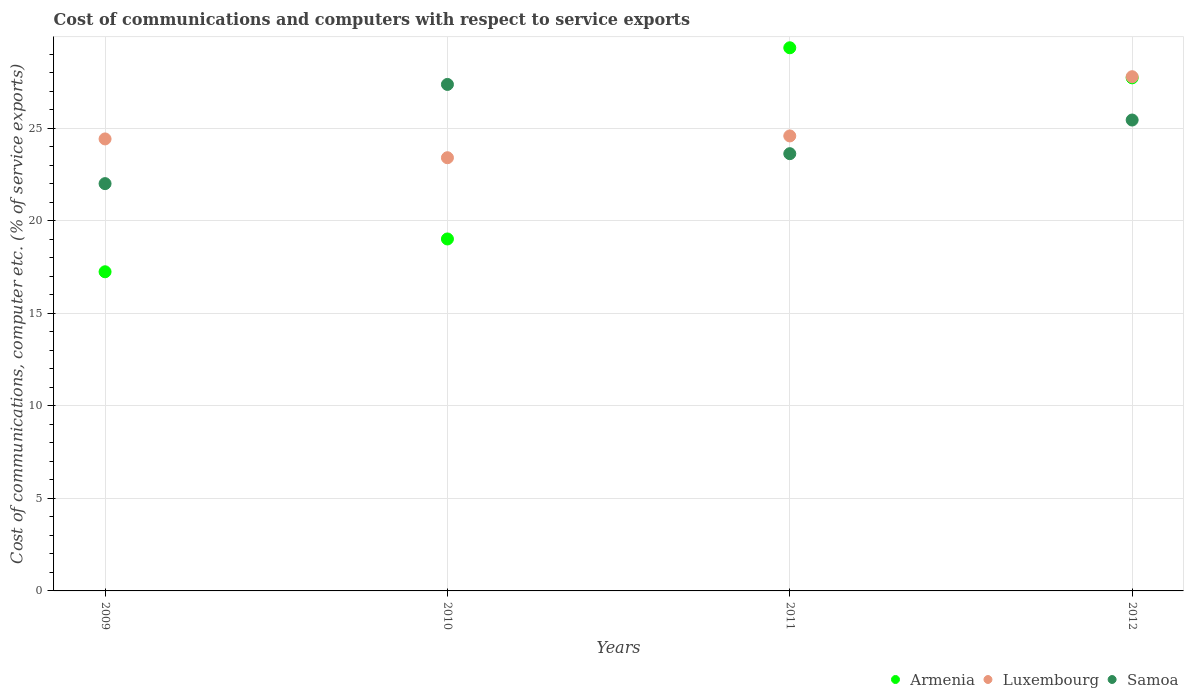Is the number of dotlines equal to the number of legend labels?
Your answer should be compact. Yes. What is the cost of communications and computers in Samoa in 2012?
Keep it short and to the point. 25.45. Across all years, what is the maximum cost of communications and computers in Samoa?
Ensure brevity in your answer.  27.37. Across all years, what is the minimum cost of communications and computers in Armenia?
Your response must be concise. 17.25. In which year was the cost of communications and computers in Samoa maximum?
Offer a very short reply. 2010. What is the total cost of communications and computers in Luxembourg in the graph?
Give a very brief answer. 100.22. What is the difference between the cost of communications and computers in Luxembourg in 2009 and that in 2011?
Give a very brief answer. -0.16. What is the difference between the cost of communications and computers in Luxembourg in 2011 and the cost of communications and computers in Armenia in 2012?
Ensure brevity in your answer.  -3.14. What is the average cost of communications and computers in Luxembourg per year?
Your answer should be very brief. 25.06. In the year 2011, what is the difference between the cost of communications and computers in Luxembourg and cost of communications and computers in Samoa?
Provide a short and direct response. 0.96. What is the ratio of the cost of communications and computers in Luxembourg in 2010 to that in 2011?
Ensure brevity in your answer.  0.95. Is the cost of communications and computers in Luxembourg in 2009 less than that in 2012?
Provide a short and direct response. Yes. Is the difference between the cost of communications and computers in Luxembourg in 2009 and 2010 greater than the difference between the cost of communications and computers in Samoa in 2009 and 2010?
Ensure brevity in your answer.  Yes. What is the difference between the highest and the second highest cost of communications and computers in Armenia?
Your answer should be very brief. 1.62. What is the difference between the highest and the lowest cost of communications and computers in Luxembourg?
Offer a terse response. 4.38. In how many years, is the cost of communications and computers in Armenia greater than the average cost of communications and computers in Armenia taken over all years?
Offer a very short reply. 2. Is the sum of the cost of communications and computers in Armenia in 2009 and 2012 greater than the maximum cost of communications and computers in Luxembourg across all years?
Keep it short and to the point. Yes. Is the cost of communications and computers in Armenia strictly greater than the cost of communications and computers in Luxembourg over the years?
Provide a succinct answer. No. Is the cost of communications and computers in Samoa strictly less than the cost of communications and computers in Luxembourg over the years?
Give a very brief answer. No. How many dotlines are there?
Ensure brevity in your answer.  3. How many years are there in the graph?
Make the answer very short. 4. What is the difference between two consecutive major ticks on the Y-axis?
Your response must be concise. 5. Are the values on the major ticks of Y-axis written in scientific E-notation?
Your response must be concise. No. Does the graph contain any zero values?
Keep it short and to the point. No. Does the graph contain grids?
Keep it short and to the point. Yes. What is the title of the graph?
Keep it short and to the point. Cost of communications and computers with respect to service exports. Does "Canada" appear as one of the legend labels in the graph?
Give a very brief answer. No. What is the label or title of the X-axis?
Provide a short and direct response. Years. What is the label or title of the Y-axis?
Your response must be concise. Cost of communications, computer etc. (% of service exports). What is the Cost of communications, computer etc. (% of service exports) of Armenia in 2009?
Your response must be concise. 17.25. What is the Cost of communications, computer etc. (% of service exports) of Luxembourg in 2009?
Offer a terse response. 24.43. What is the Cost of communications, computer etc. (% of service exports) of Samoa in 2009?
Your answer should be very brief. 22.01. What is the Cost of communications, computer etc. (% of service exports) in Armenia in 2010?
Your answer should be very brief. 19.02. What is the Cost of communications, computer etc. (% of service exports) of Luxembourg in 2010?
Ensure brevity in your answer.  23.41. What is the Cost of communications, computer etc. (% of service exports) of Samoa in 2010?
Provide a succinct answer. 27.37. What is the Cost of communications, computer etc. (% of service exports) in Armenia in 2011?
Provide a short and direct response. 29.35. What is the Cost of communications, computer etc. (% of service exports) in Luxembourg in 2011?
Provide a succinct answer. 24.59. What is the Cost of communications, computer etc. (% of service exports) in Samoa in 2011?
Provide a short and direct response. 23.63. What is the Cost of communications, computer etc. (% of service exports) in Armenia in 2012?
Ensure brevity in your answer.  27.73. What is the Cost of communications, computer etc. (% of service exports) of Luxembourg in 2012?
Give a very brief answer. 27.79. What is the Cost of communications, computer etc. (% of service exports) in Samoa in 2012?
Ensure brevity in your answer.  25.45. Across all years, what is the maximum Cost of communications, computer etc. (% of service exports) of Armenia?
Provide a short and direct response. 29.35. Across all years, what is the maximum Cost of communications, computer etc. (% of service exports) in Luxembourg?
Your response must be concise. 27.79. Across all years, what is the maximum Cost of communications, computer etc. (% of service exports) of Samoa?
Offer a terse response. 27.37. Across all years, what is the minimum Cost of communications, computer etc. (% of service exports) in Armenia?
Make the answer very short. 17.25. Across all years, what is the minimum Cost of communications, computer etc. (% of service exports) of Luxembourg?
Make the answer very short. 23.41. Across all years, what is the minimum Cost of communications, computer etc. (% of service exports) of Samoa?
Keep it short and to the point. 22.01. What is the total Cost of communications, computer etc. (% of service exports) of Armenia in the graph?
Offer a terse response. 93.35. What is the total Cost of communications, computer etc. (% of service exports) of Luxembourg in the graph?
Keep it short and to the point. 100.22. What is the total Cost of communications, computer etc. (% of service exports) of Samoa in the graph?
Provide a succinct answer. 98.47. What is the difference between the Cost of communications, computer etc. (% of service exports) of Armenia in 2009 and that in 2010?
Offer a very short reply. -1.77. What is the difference between the Cost of communications, computer etc. (% of service exports) of Luxembourg in 2009 and that in 2010?
Your answer should be very brief. 1.02. What is the difference between the Cost of communications, computer etc. (% of service exports) of Samoa in 2009 and that in 2010?
Give a very brief answer. -5.36. What is the difference between the Cost of communications, computer etc. (% of service exports) of Armenia in 2009 and that in 2011?
Your answer should be very brief. -12.11. What is the difference between the Cost of communications, computer etc. (% of service exports) in Luxembourg in 2009 and that in 2011?
Offer a terse response. -0.16. What is the difference between the Cost of communications, computer etc. (% of service exports) in Samoa in 2009 and that in 2011?
Your answer should be very brief. -1.62. What is the difference between the Cost of communications, computer etc. (% of service exports) of Armenia in 2009 and that in 2012?
Ensure brevity in your answer.  -10.48. What is the difference between the Cost of communications, computer etc. (% of service exports) in Luxembourg in 2009 and that in 2012?
Ensure brevity in your answer.  -3.36. What is the difference between the Cost of communications, computer etc. (% of service exports) of Samoa in 2009 and that in 2012?
Provide a short and direct response. -3.44. What is the difference between the Cost of communications, computer etc. (% of service exports) in Armenia in 2010 and that in 2011?
Provide a short and direct response. -10.33. What is the difference between the Cost of communications, computer etc. (% of service exports) in Luxembourg in 2010 and that in 2011?
Offer a very short reply. -1.18. What is the difference between the Cost of communications, computer etc. (% of service exports) in Samoa in 2010 and that in 2011?
Make the answer very short. 3.74. What is the difference between the Cost of communications, computer etc. (% of service exports) in Armenia in 2010 and that in 2012?
Ensure brevity in your answer.  -8.71. What is the difference between the Cost of communications, computer etc. (% of service exports) in Luxembourg in 2010 and that in 2012?
Your answer should be compact. -4.38. What is the difference between the Cost of communications, computer etc. (% of service exports) in Samoa in 2010 and that in 2012?
Keep it short and to the point. 1.92. What is the difference between the Cost of communications, computer etc. (% of service exports) in Armenia in 2011 and that in 2012?
Make the answer very short. 1.62. What is the difference between the Cost of communications, computer etc. (% of service exports) in Luxembourg in 2011 and that in 2012?
Offer a terse response. -3.2. What is the difference between the Cost of communications, computer etc. (% of service exports) in Samoa in 2011 and that in 2012?
Give a very brief answer. -1.82. What is the difference between the Cost of communications, computer etc. (% of service exports) of Armenia in 2009 and the Cost of communications, computer etc. (% of service exports) of Luxembourg in 2010?
Provide a short and direct response. -6.16. What is the difference between the Cost of communications, computer etc. (% of service exports) in Armenia in 2009 and the Cost of communications, computer etc. (% of service exports) in Samoa in 2010?
Keep it short and to the point. -10.13. What is the difference between the Cost of communications, computer etc. (% of service exports) in Luxembourg in 2009 and the Cost of communications, computer etc. (% of service exports) in Samoa in 2010?
Your answer should be very brief. -2.95. What is the difference between the Cost of communications, computer etc. (% of service exports) of Armenia in 2009 and the Cost of communications, computer etc. (% of service exports) of Luxembourg in 2011?
Offer a very short reply. -7.34. What is the difference between the Cost of communications, computer etc. (% of service exports) in Armenia in 2009 and the Cost of communications, computer etc. (% of service exports) in Samoa in 2011?
Your answer should be compact. -6.38. What is the difference between the Cost of communications, computer etc. (% of service exports) of Luxembourg in 2009 and the Cost of communications, computer etc. (% of service exports) of Samoa in 2011?
Your answer should be very brief. 0.8. What is the difference between the Cost of communications, computer etc. (% of service exports) of Armenia in 2009 and the Cost of communications, computer etc. (% of service exports) of Luxembourg in 2012?
Your answer should be compact. -10.54. What is the difference between the Cost of communications, computer etc. (% of service exports) of Armenia in 2009 and the Cost of communications, computer etc. (% of service exports) of Samoa in 2012?
Keep it short and to the point. -8.2. What is the difference between the Cost of communications, computer etc. (% of service exports) of Luxembourg in 2009 and the Cost of communications, computer etc. (% of service exports) of Samoa in 2012?
Offer a terse response. -1.02. What is the difference between the Cost of communications, computer etc. (% of service exports) of Armenia in 2010 and the Cost of communications, computer etc. (% of service exports) of Luxembourg in 2011?
Provide a succinct answer. -5.57. What is the difference between the Cost of communications, computer etc. (% of service exports) in Armenia in 2010 and the Cost of communications, computer etc. (% of service exports) in Samoa in 2011?
Your response must be concise. -4.61. What is the difference between the Cost of communications, computer etc. (% of service exports) in Luxembourg in 2010 and the Cost of communications, computer etc. (% of service exports) in Samoa in 2011?
Provide a short and direct response. -0.22. What is the difference between the Cost of communications, computer etc. (% of service exports) in Armenia in 2010 and the Cost of communications, computer etc. (% of service exports) in Luxembourg in 2012?
Give a very brief answer. -8.77. What is the difference between the Cost of communications, computer etc. (% of service exports) of Armenia in 2010 and the Cost of communications, computer etc. (% of service exports) of Samoa in 2012?
Provide a succinct answer. -6.43. What is the difference between the Cost of communications, computer etc. (% of service exports) of Luxembourg in 2010 and the Cost of communications, computer etc. (% of service exports) of Samoa in 2012?
Ensure brevity in your answer.  -2.04. What is the difference between the Cost of communications, computer etc. (% of service exports) of Armenia in 2011 and the Cost of communications, computer etc. (% of service exports) of Luxembourg in 2012?
Your answer should be compact. 1.56. What is the difference between the Cost of communications, computer etc. (% of service exports) in Armenia in 2011 and the Cost of communications, computer etc. (% of service exports) in Samoa in 2012?
Ensure brevity in your answer.  3.9. What is the difference between the Cost of communications, computer etc. (% of service exports) of Luxembourg in 2011 and the Cost of communications, computer etc. (% of service exports) of Samoa in 2012?
Your response must be concise. -0.86. What is the average Cost of communications, computer etc. (% of service exports) in Armenia per year?
Provide a short and direct response. 23.34. What is the average Cost of communications, computer etc. (% of service exports) in Luxembourg per year?
Provide a succinct answer. 25.06. What is the average Cost of communications, computer etc. (% of service exports) in Samoa per year?
Offer a very short reply. 24.62. In the year 2009, what is the difference between the Cost of communications, computer etc. (% of service exports) of Armenia and Cost of communications, computer etc. (% of service exports) of Luxembourg?
Give a very brief answer. -7.18. In the year 2009, what is the difference between the Cost of communications, computer etc. (% of service exports) in Armenia and Cost of communications, computer etc. (% of service exports) in Samoa?
Your answer should be compact. -4.76. In the year 2009, what is the difference between the Cost of communications, computer etc. (% of service exports) in Luxembourg and Cost of communications, computer etc. (% of service exports) in Samoa?
Make the answer very short. 2.42. In the year 2010, what is the difference between the Cost of communications, computer etc. (% of service exports) in Armenia and Cost of communications, computer etc. (% of service exports) in Luxembourg?
Your answer should be very brief. -4.39. In the year 2010, what is the difference between the Cost of communications, computer etc. (% of service exports) in Armenia and Cost of communications, computer etc. (% of service exports) in Samoa?
Provide a succinct answer. -8.35. In the year 2010, what is the difference between the Cost of communications, computer etc. (% of service exports) of Luxembourg and Cost of communications, computer etc. (% of service exports) of Samoa?
Your answer should be very brief. -3.96. In the year 2011, what is the difference between the Cost of communications, computer etc. (% of service exports) in Armenia and Cost of communications, computer etc. (% of service exports) in Luxembourg?
Your answer should be very brief. 4.76. In the year 2011, what is the difference between the Cost of communications, computer etc. (% of service exports) in Armenia and Cost of communications, computer etc. (% of service exports) in Samoa?
Your answer should be very brief. 5.72. In the year 2011, what is the difference between the Cost of communications, computer etc. (% of service exports) of Luxembourg and Cost of communications, computer etc. (% of service exports) of Samoa?
Make the answer very short. 0.96. In the year 2012, what is the difference between the Cost of communications, computer etc. (% of service exports) in Armenia and Cost of communications, computer etc. (% of service exports) in Luxembourg?
Provide a succinct answer. -0.06. In the year 2012, what is the difference between the Cost of communications, computer etc. (% of service exports) of Armenia and Cost of communications, computer etc. (% of service exports) of Samoa?
Your answer should be very brief. 2.28. In the year 2012, what is the difference between the Cost of communications, computer etc. (% of service exports) of Luxembourg and Cost of communications, computer etc. (% of service exports) of Samoa?
Your response must be concise. 2.34. What is the ratio of the Cost of communications, computer etc. (% of service exports) of Armenia in 2009 to that in 2010?
Offer a terse response. 0.91. What is the ratio of the Cost of communications, computer etc. (% of service exports) in Luxembourg in 2009 to that in 2010?
Offer a terse response. 1.04. What is the ratio of the Cost of communications, computer etc. (% of service exports) in Samoa in 2009 to that in 2010?
Offer a very short reply. 0.8. What is the ratio of the Cost of communications, computer etc. (% of service exports) in Armenia in 2009 to that in 2011?
Make the answer very short. 0.59. What is the ratio of the Cost of communications, computer etc. (% of service exports) of Samoa in 2009 to that in 2011?
Ensure brevity in your answer.  0.93. What is the ratio of the Cost of communications, computer etc. (% of service exports) in Armenia in 2009 to that in 2012?
Ensure brevity in your answer.  0.62. What is the ratio of the Cost of communications, computer etc. (% of service exports) of Luxembourg in 2009 to that in 2012?
Provide a succinct answer. 0.88. What is the ratio of the Cost of communications, computer etc. (% of service exports) of Samoa in 2009 to that in 2012?
Offer a terse response. 0.86. What is the ratio of the Cost of communications, computer etc. (% of service exports) of Armenia in 2010 to that in 2011?
Your response must be concise. 0.65. What is the ratio of the Cost of communications, computer etc. (% of service exports) of Luxembourg in 2010 to that in 2011?
Provide a short and direct response. 0.95. What is the ratio of the Cost of communications, computer etc. (% of service exports) of Samoa in 2010 to that in 2011?
Provide a succinct answer. 1.16. What is the ratio of the Cost of communications, computer etc. (% of service exports) of Armenia in 2010 to that in 2012?
Make the answer very short. 0.69. What is the ratio of the Cost of communications, computer etc. (% of service exports) in Luxembourg in 2010 to that in 2012?
Your response must be concise. 0.84. What is the ratio of the Cost of communications, computer etc. (% of service exports) of Samoa in 2010 to that in 2012?
Offer a terse response. 1.08. What is the ratio of the Cost of communications, computer etc. (% of service exports) of Armenia in 2011 to that in 2012?
Give a very brief answer. 1.06. What is the ratio of the Cost of communications, computer etc. (% of service exports) in Luxembourg in 2011 to that in 2012?
Your response must be concise. 0.88. What is the ratio of the Cost of communications, computer etc. (% of service exports) of Samoa in 2011 to that in 2012?
Provide a succinct answer. 0.93. What is the difference between the highest and the second highest Cost of communications, computer etc. (% of service exports) of Armenia?
Ensure brevity in your answer.  1.62. What is the difference between the highest and the second highest Cost of communications, computer etc. (% of service exports) in Luxembourg?
Ensure brevity in your answer.  3.2. What is the difference between the highest and the second highest Cost of communications, computer etc. (% of service exports) of Samoa?
Make the answer very short. 1.92. What is the difference between the highest and the lowest Cost of communications, computer etc. (% of service exports) of Armenia?
Ensure brevity in your answer.  12.11. What is the difference between the highest and the lowest Cost of communications, computer etc. (% of service exports) of Luxembourg?
Give a very brief answer. 4.38. What is the difference between the highest and the lowest Cost of communications, computer etc. (% of service exports) of Samoa?
Keep it short and to the point. 5.36. 